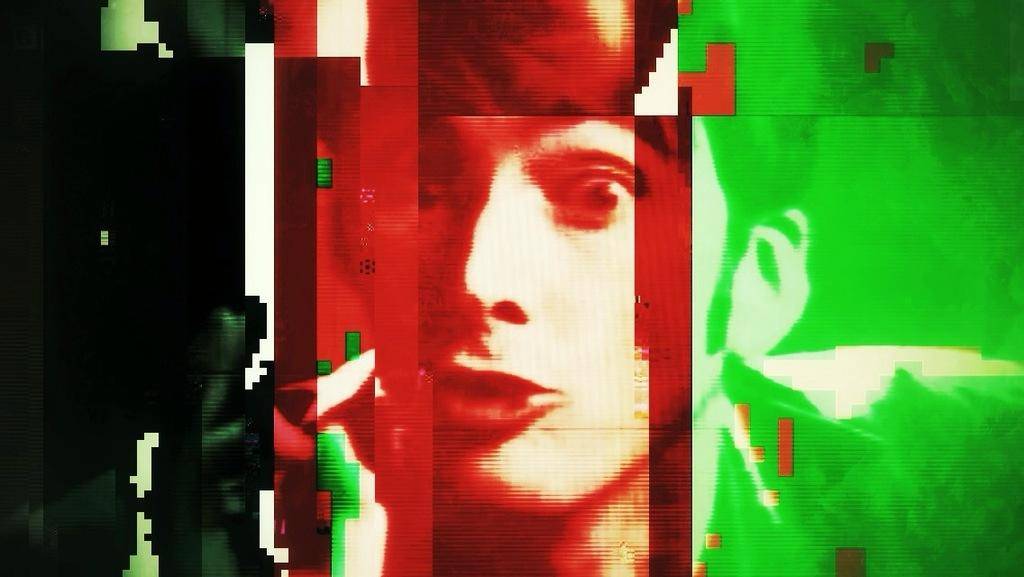What can be observed about the nature of the image? The image is edited. What is the main subject of the image? There is a person's face in the middle of the image. What type of rod is being used to pull the person's face in the image? There is no rod or pulling action present in the image; it features a person's face in the middle of the image. How many spades are visible in the image? There are no spades present in the image. 